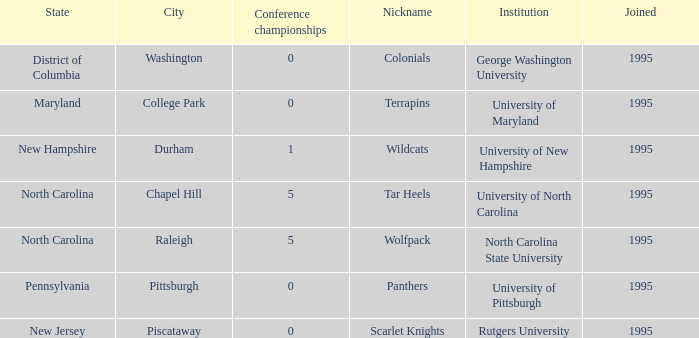What is the year joined with a Conference championships of 5, and a Nickname of wolfpack? 1995.0. 